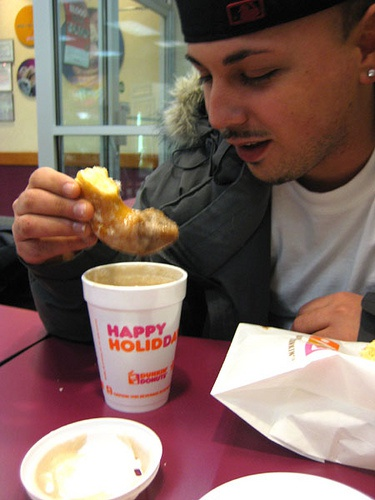Describe the objects in this image and their specific colors. I can see people in tan, black, maroon, and gray tones, dining table in tan, maroon, brown, and black tones, cup in tan, darkgray, and lightgray tones, bowl in tan, ivory, khaki, pink, and brown tones, and donut in tan, brown, maroon, and khaki tones in this image. 